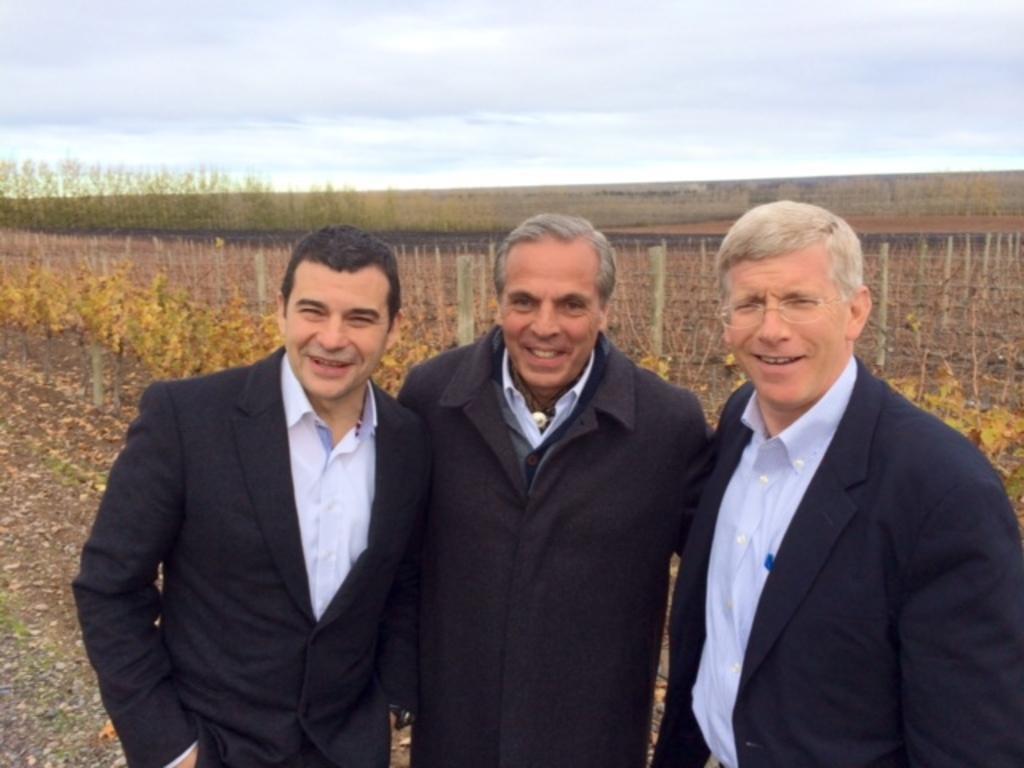Describe this image in one or two sentences. In this picture we can see there are three people standing and behind the people there is a fence, trees and the sky. 